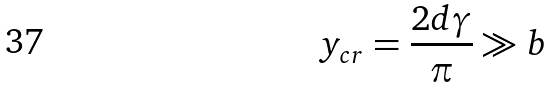<formula> <loc_0><loc_0><loc_500><loc_500>y _ { c r } = \frac { 2 d \gamma } { \pi } \gg b</formula> 